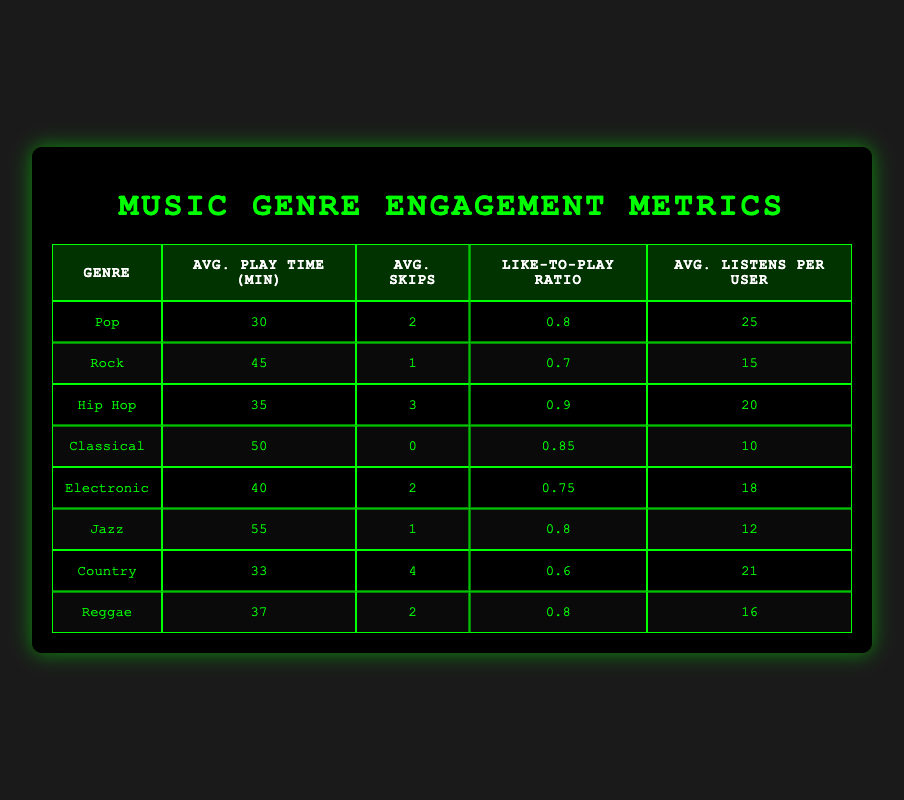What genre has the highest average play time? The average play time for each genre is listed in the table. By comparing the values, Jazz has the highest average play time at 55 minutes.
Answer: Jazz How many skips does the Pop genre have on average? The table indicates that the average skips for the Pop genre is listed, which is 2.
Answer: 2 Which genres have a like-to-play ratio above 0.8? The table shows that the like-to-play ratio for Pop (0.8), Hip Hop (0.9), Classical (0.85), Jazz (0.8), and Reggae (0.8) are above 0.8.
Answer: Pop, Hip Hop, Classical, Jazz, Reggae What is the difference in average play time between Classical and Country genres? The average play time for Classical is 50 minutes, and for Country, it is 33 minutes. The difference is 50 - 33 = 17 minutes.
Answer: 17 minutes Is the average listens per user for Rock genre greater than for Jazz genre? The average listens per user for Rock is 15, and for Jazz, it is 12. Since 15 is greater than 12, the answer is yes.
Answer: Yes What is the average number of skips across all genres? To find the average skips, we add all the skips: (2 + 1 + 3 + 0 + 2 + 1 + 4 + 2) = 15. There are 8 genres, so the average is 15 / 8 = 1.875.
Answer: 1.875 Which genre has the lowest average listens per user? By checking the average listens per user for each genre, Classical has the lowest value at 10.
Answer: Classical Do Electronic and Hip Hop have the same average play time? The average play time for Electronic is 40 minutes and for Hip Hop, it is 35 minutes. Since these are different, the answer is no.
Answer: No What would be the average play time if we only consider genres with a like-to-play ratio less than 0.8? The genres with a like-to-play ratio less than 0.8 are Rock (45), and Country (33). The average play time is (45 + 33) / 2 = 39 minutes.
Answer: 39 minutes 